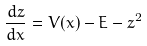<formula> <loc_0><loc_0><loc_500><loc_500>\frac { d z } { d x } = V ( x ) - E - z ^ { 2 }</formula> 